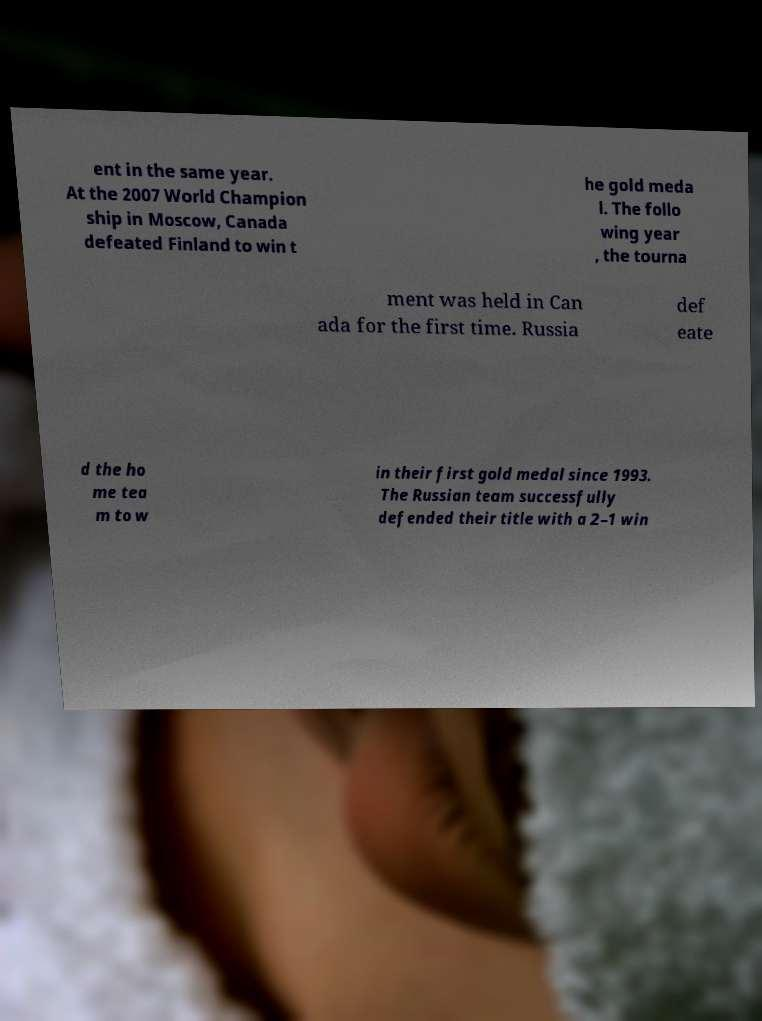I need the written content from this picture converted into text. Can you do that? ent in the same year. At the 2007 World Champion ship in Moscow, Canada defeated Finland to win t he gold meda l. The follo wing year , the tourna ment was held in Can ada for the first time. Russia def eate d the ho me tea m to w in their first gold medal since 1993. The Russian team successfully defended their title with a 2–1 win 